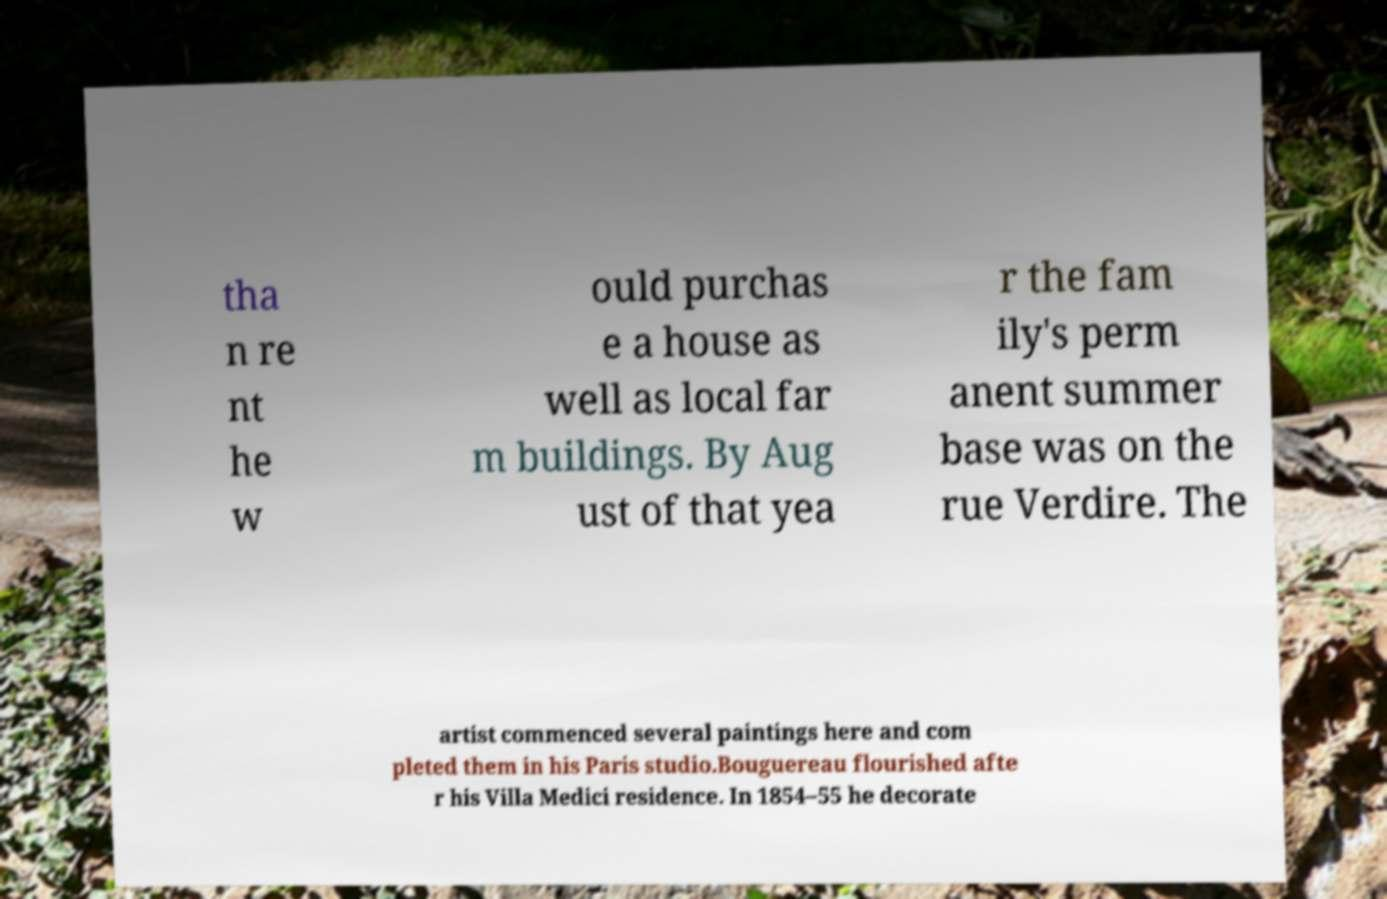Can you read and provide the text displayed in the image?This photo seems to have some interesting text. Can you extract and type it out for me? tha n re nt he w ould purchas e a house as well as local far m buildings. By Aug ust of that yea r the fam ily's perm anent summer base was on the rue Verdire. The artist commenced several paintings here and com pleted them in his Paris studio.Bouguereau flourished afte r his Villa Medici residence. In 1854–55 he decorate 